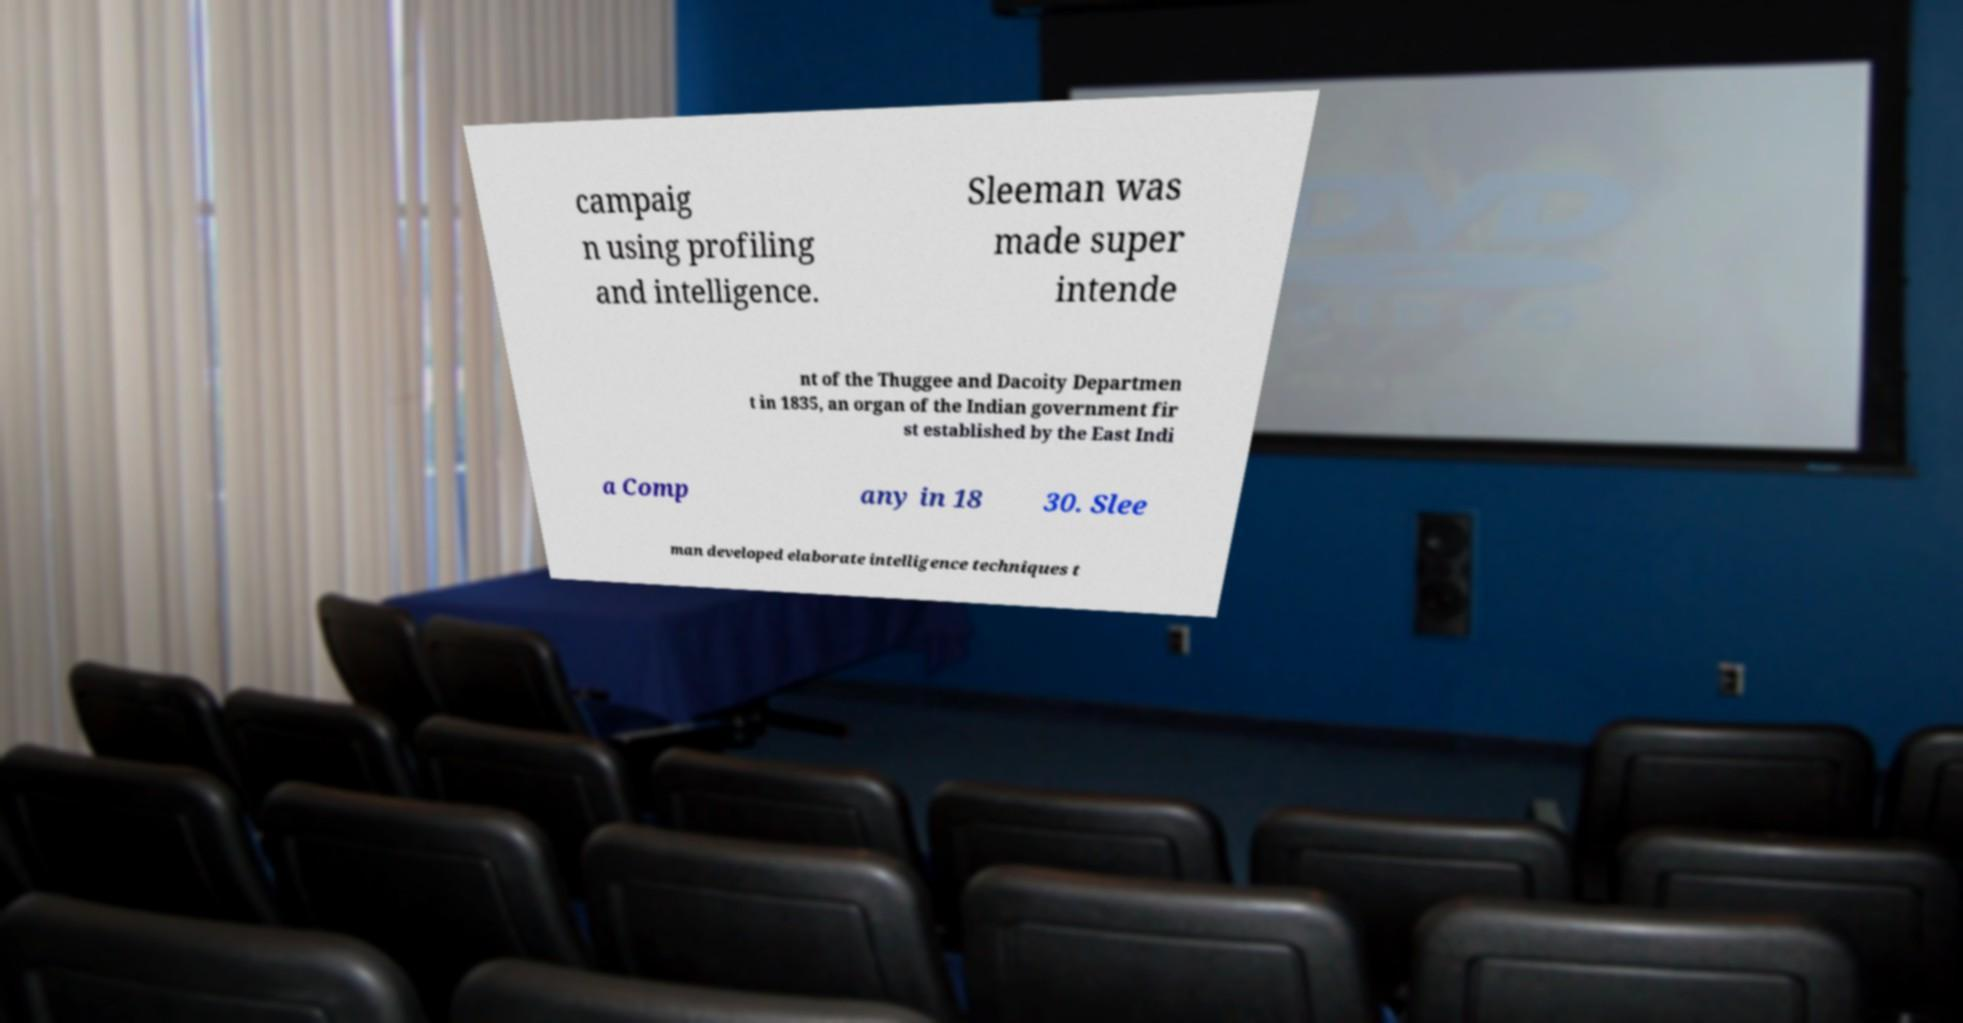Please read and relay the text visible in this image. What does it say? campaig n using profiling and intelligence. Sleeman was made super intende nt of the Thuggee and Dacoity Departmen t in 1835, an organ of the Indian government fir st established by the East Indi a Comp any in 18 30. Slee man developed elaborate intelligence techniques t 